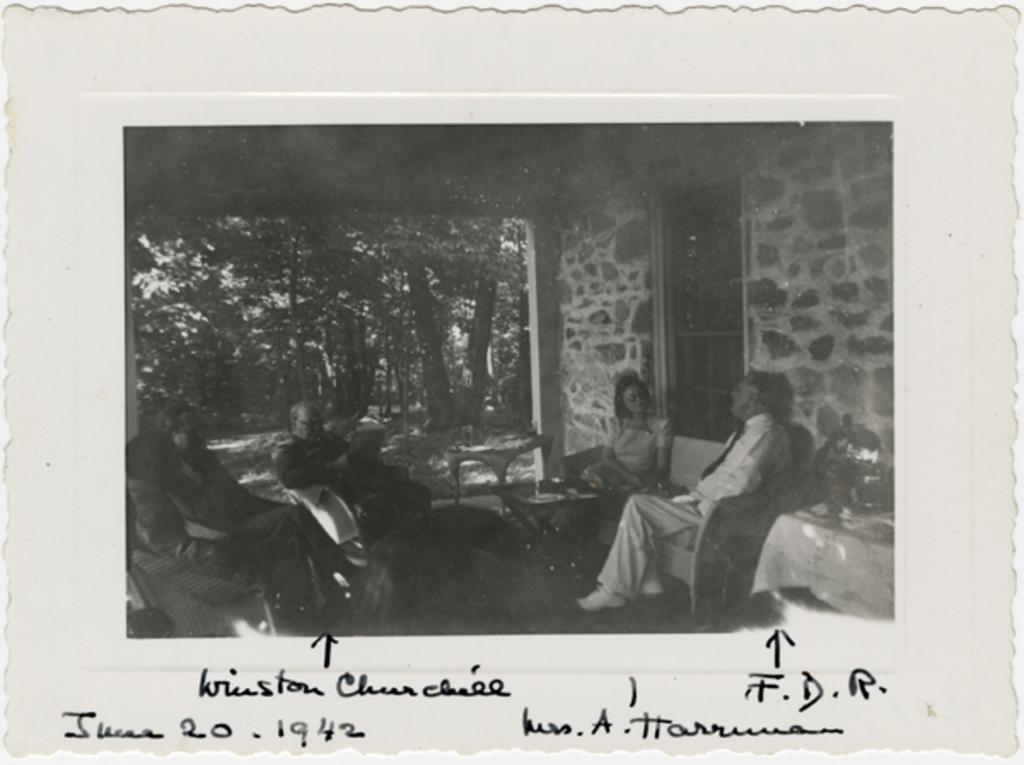Describe this image in one or two sentences. In this image there is a photograph. In the center there are people sitting. In the background there are trees. On the right there is a wall and a door. We can see a table. At the bottom there is text written. 